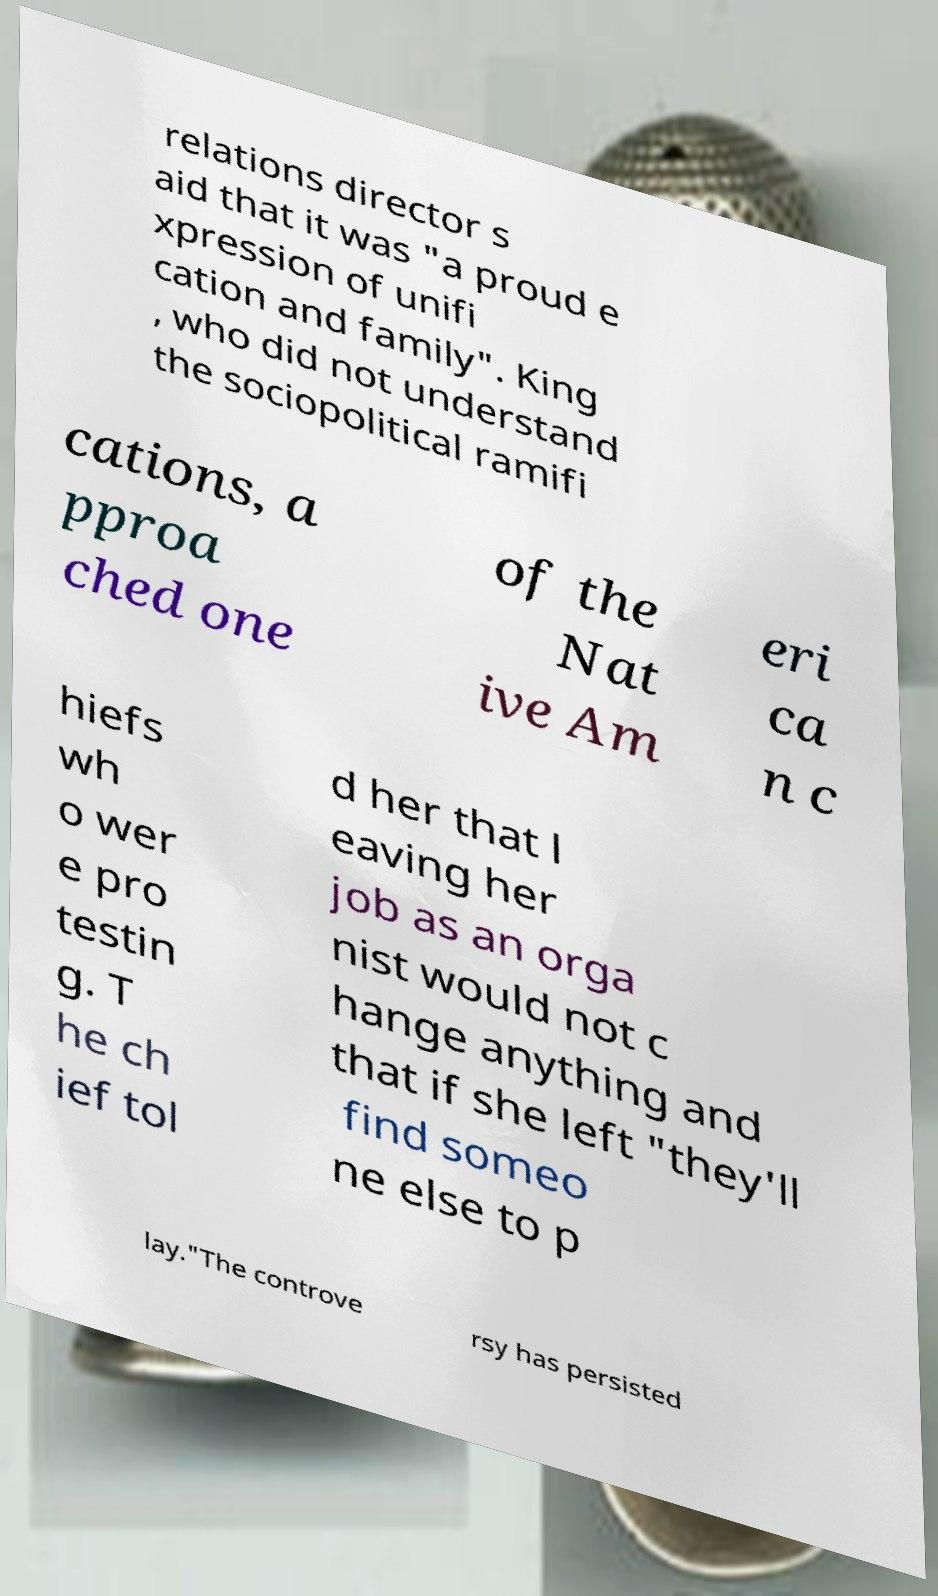Could you extract and type out the text from this image? relations director s aid that it was "a proud e xpression of unifi cation and family". King , who did not understand the sociopolitical ramifi cations, a pproa ched one of the Nat ive Am eri ca n c hiefs wh o wer e pro testin g. T he ch ief tol d her that l eaving her job as an orga nist would not c hange anything and that if she left "they'll find someo ne else to p lay."The controve rsy has persisted 